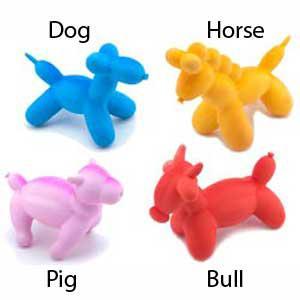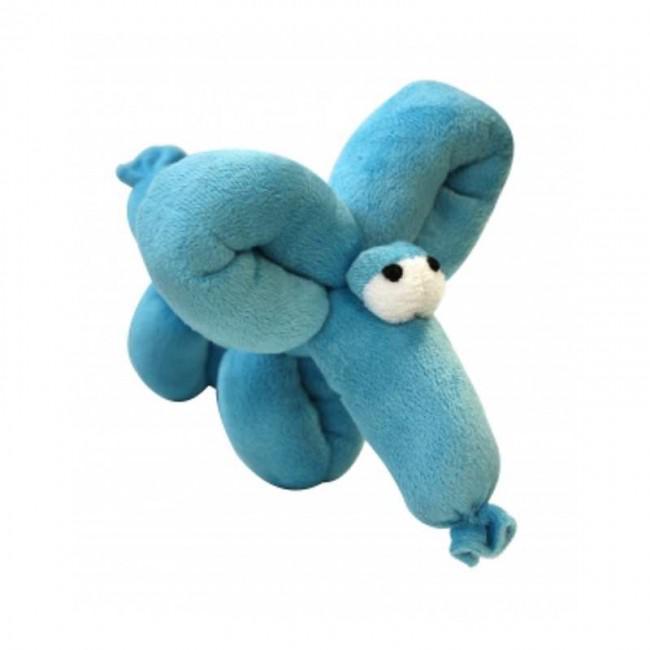The first image is the image on the left, the second image is the image on the right. Analyze the images presented: Is the assertion "One of the balloons is the shape of a lion." valid? Answer yes or no. No. 